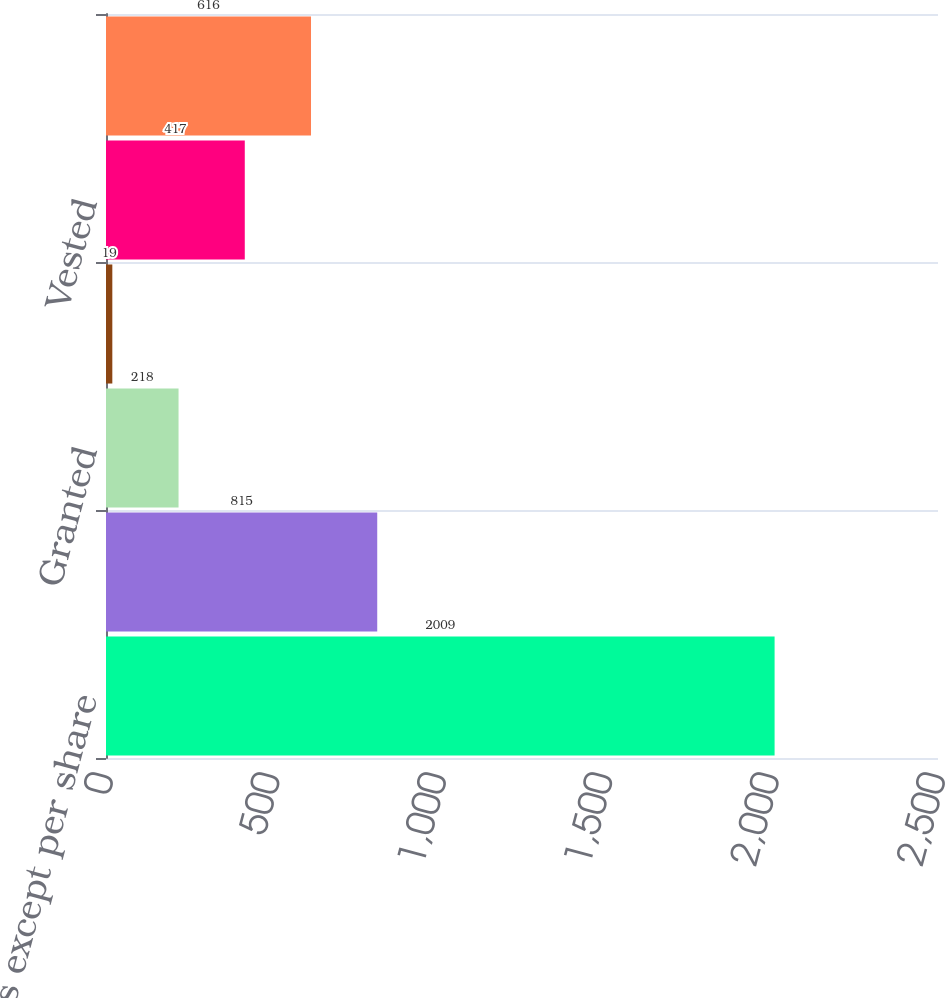Convert chart to OTSL. <chart><loc_0><loc_0><loc_500><loc_500><bar_chart><fcel>(In thousands except per share<fcel>Outstanding beginning of year<fcel>Granted<fcel>Forfeited<fcel>Vested<fcel>Outstanding end of year<nl><fcel>2009<fcel>815<fcel>218<fcel>19<fcel>417<fcel>616<nl></chart> 